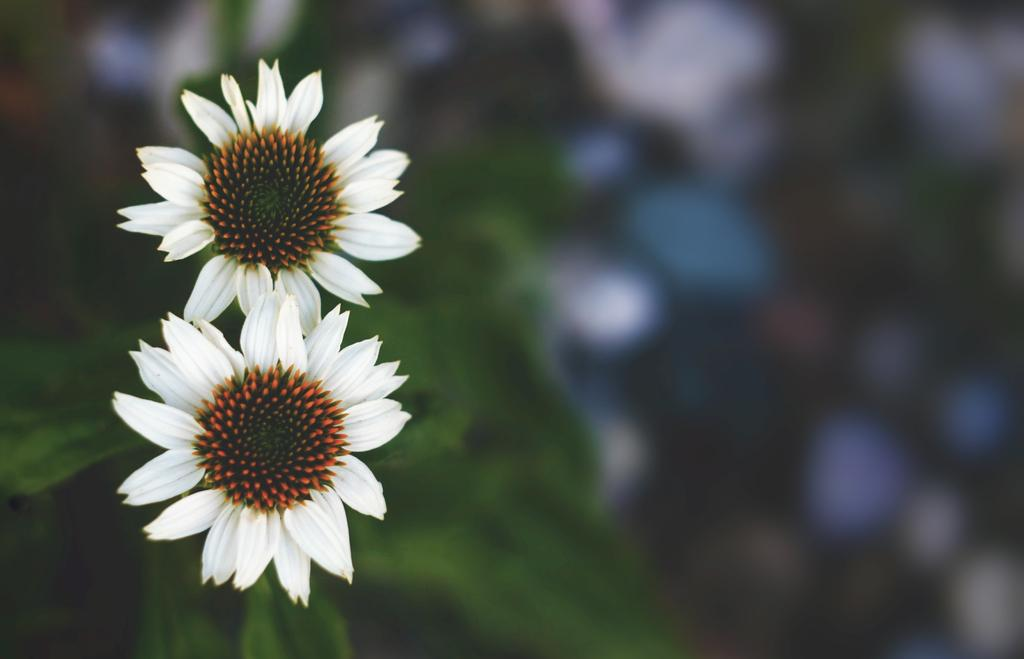What type of plants can be seen in the image? There are flowers and leaves in the image. Can you describe the appearance of the flowers? Unfortunately, the specific appearance of the flowers cannot be determined from the provided facts. What is the relationship between the flowers and leaves in the image? The flowers and leaves are likely part of the same plant, as they are both present in the image. How many fangs can be seen on the flowers in the image? There are no fangs present on the flowers in the image, as flowers do not have fangs. 